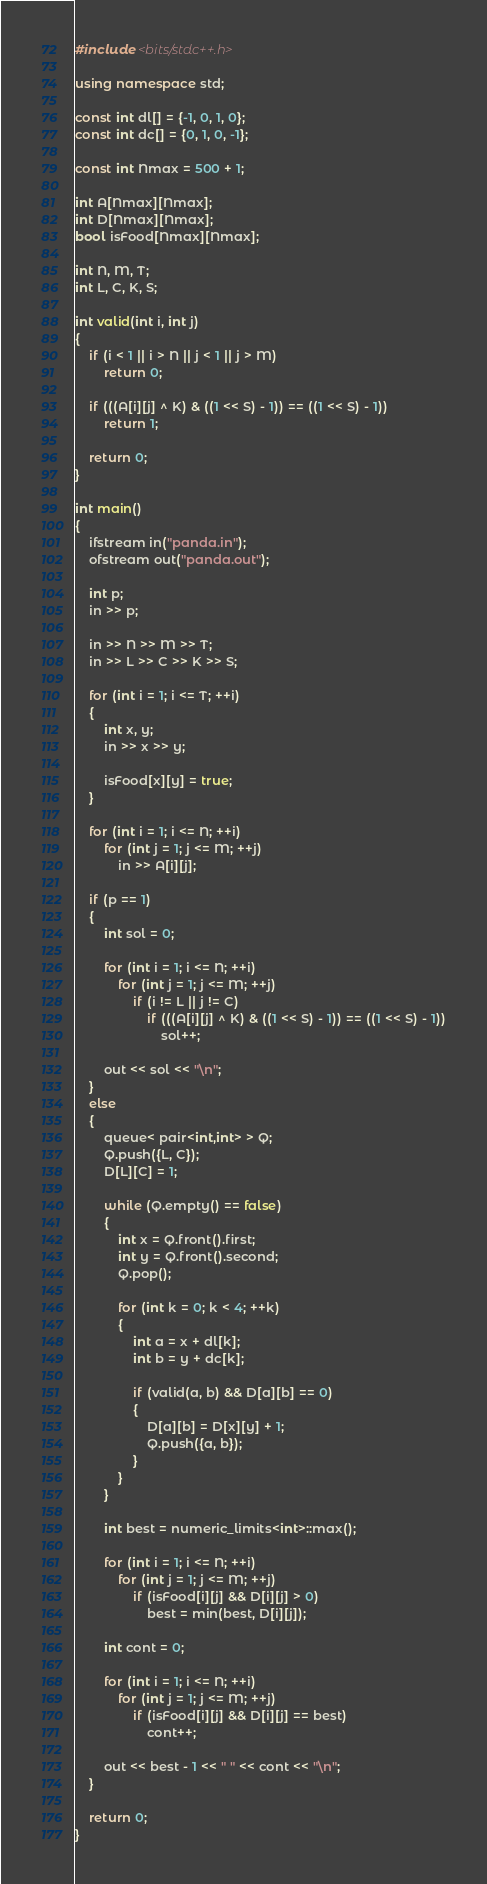<code> <loc_0><loc_0><loc_500><loc_500><_C++_>#include <bits/stdc++.h>

using namespace std;

const int dl[] = {-1, 0, 1, 0};
const int dc[] = {0, 1, 0, -1};

const int Nmax = 500 + 1;

int A[Nmax][Nmax];
int D[Nmax][Nmax];
bool isFood[Nmax][Nmax];

int N, M, T;
int L, C, K, S;

int valid(int i, int j)
{
    if (i < 1 || i > N || j < 1 || j > M)
        return 0;

    if (((A[i][j] ^ K) & ((1 << S) - 1)) == ((1 << S) - 1))
        return 1;

    return 0;
}

int main()
{
    ifstream in("panda.in");
    ofstream out("panda.out");

    int p;
    in >> p;

    in >> N >> M >> T;
    in >> L >> C >> K >> S;

    for (int i = 1; i <= T; ++i)
    {
        int x, y;
        in >> x >> y;

        isFood[x][y] = true;
    }

    for (int i = 1; i <= N; ++i)
        for (int j = 1; j <= M; ++j)
            in >> A[i][j];

    if (p == 1)
    {
        int sol = 0;

        for (int i = 1; i <= N; ++i)
            for (int j = 1; j <= M; ++j)
                if (i != L || j != C)
                    if (((A[i][j] ^ K) & ((1 << S) - 1)) == ((1 << S) - 1))
                        sol++;

        out << sol << "\n";
    }
    else
    {
        queue< pair<int,int> > Q;
        Q.push({L, C});
        D[L][C] = 1;

        while (Q.empty() == false)
        {
            int x = Q.front().first;
            int y = Q.front().second;
            Q.pop();

            for (int k = 0; k < 4; ++k)
            {
                int a = x + dl[k];
                int b = y + dc[k];

                if (valid(a, b) && D[a][b] == 0)
                {
                    D[a][b] = D[x][y] + 1;
                    Q.push({a, b});
                }
            }
        }

        int best = numeric_limits<int>::max();

        for (int i = 1; i <= N; ++i)
            for (int j = 1; j <= M; ++j)
                if (isFood[i][j] && D[i][j] > 0)
                    best = min(best, D[i][j]);

        int cont = 0;

        for (int i = 1; i <= N; ++i)
            for (int j = 1; j <= M; ++j)
                if (isFood[i][j] && D[i][j] == best)
                    cont++;

        out << best - 1 << " " << cont << "\n";
    }

    return 0;
}
</code> 